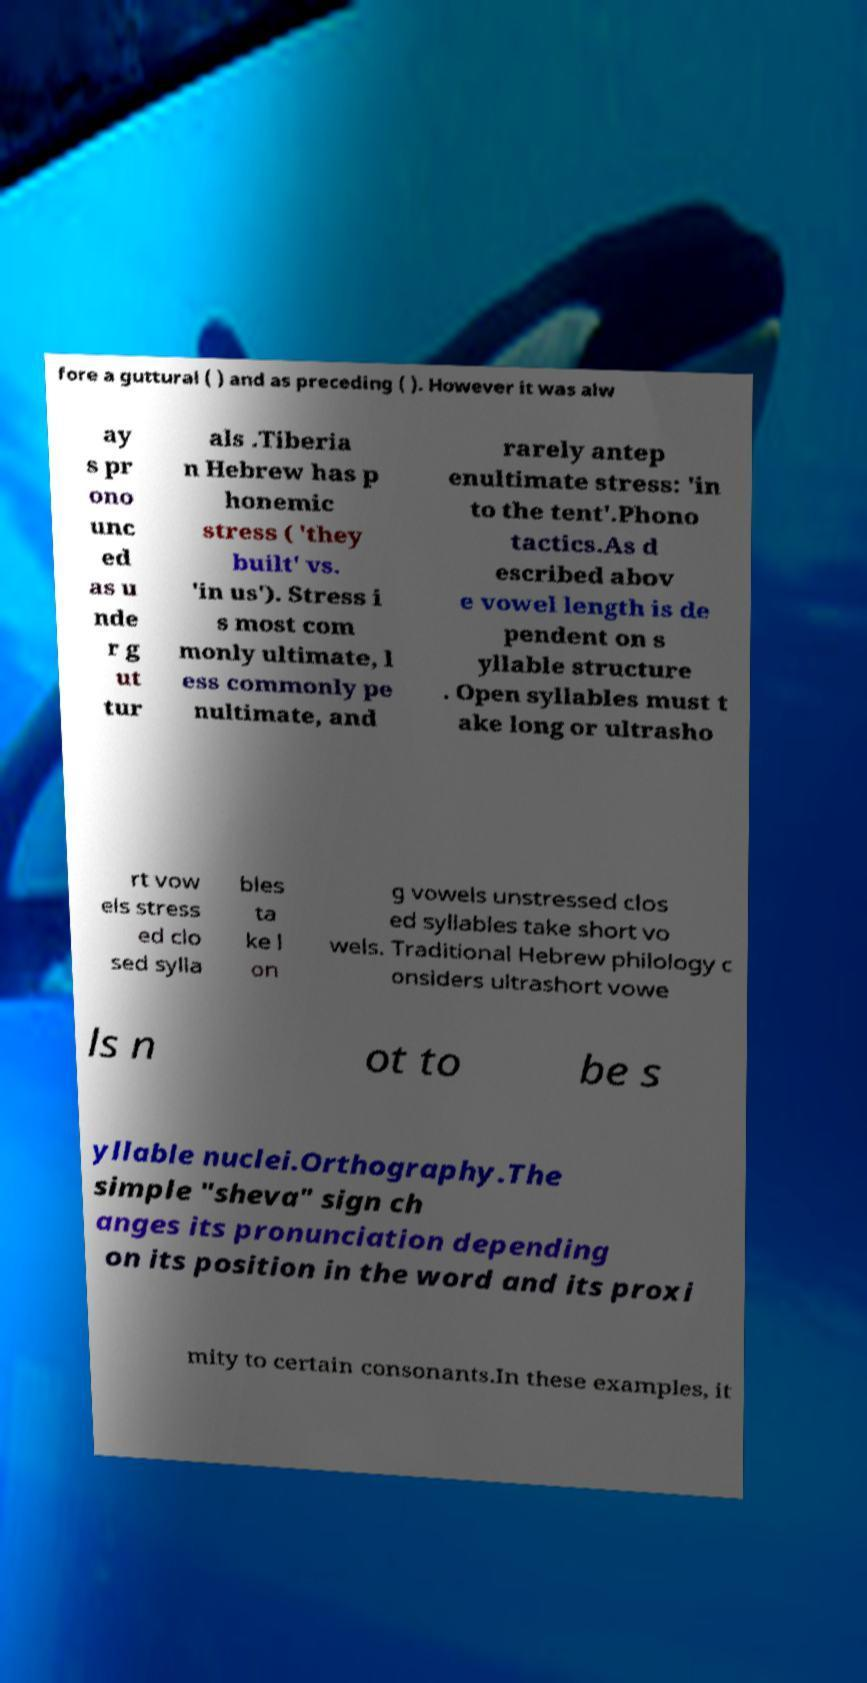Please identify and transcribe the text found in this image. fore a guttural ( ) and as preceding ( ). However it was alw ay s pr ono unc ed as u nde r g ut tur als .Tiberia n Hebrew has p honemic stress ( 'they built' vs. 'in us'). Stress i s most com monly ultimate, l ess commonly pe nultimate, and rarely antep enultimate stress: 'in to the tent'.Phono tactics.As d escribed abov e vowel length is de pendent on s yllable structure . Open syllables must t ake long or ultrasho rt vow els stress ed clo sed sylla bles ta ke l on g vowels unstressed clos ed syllables take short vo wels. Traditional Hebrew philology c onsiders ultrashort vowe ls n ot to be s yllable nuclei.Orthography.The simple "sheva" sign ch anges its pronunciation depending on its position in the word and its proxi mity to certain consonants.In these examples, it 